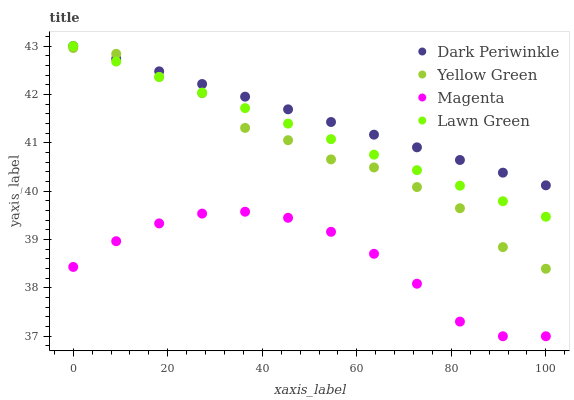Does Magenta have the minimum area under the curve?
Answer yes or no. Yes. Does Dark Periwinkle have the maximum area under the curve?
Answer yes or no. Yes. Does Dark Periwinkle have the minimum area under the curve?
Answer yes or no. No. Does Magenta have the maximum area under the curve?
Answer yes or no. No. Is Lawn Green the smoothest?
Answer yes or no. Yes. Is Yellow Green the roughest?
Answer yes or no. Yes. Is Magenta the smoothest?
Answer yes or no. No. Is Magenta the roughest?
Answer yes or no. No. Does Magenta have the lowest value?
Answer yes or no. Yes. Does Dark Periwinkle have the lowest value?
Answer yes or no. No. Does Dark Periwinkle have the highest value?
Answer yes or no. Yes. Does Magenta have the highest value?
Answer yes or no. No. Is Magenta less than Lawn Green?
Answer yes or no. Yes. Is Yellow Green greater than Magenta?
Answer yes or no. Yes. Does Dark Periwinkle intersect Lawn Green?
Answer yes or no. Yes. Is Dark Periwinkle less than Lawn Green?
Answer yes or no. No. Is Dark Periwinkle greater than Lawn Green?
Answer yes or no. No. Does Magenta intersect Lawn Green?
Answer yes or no. No. 